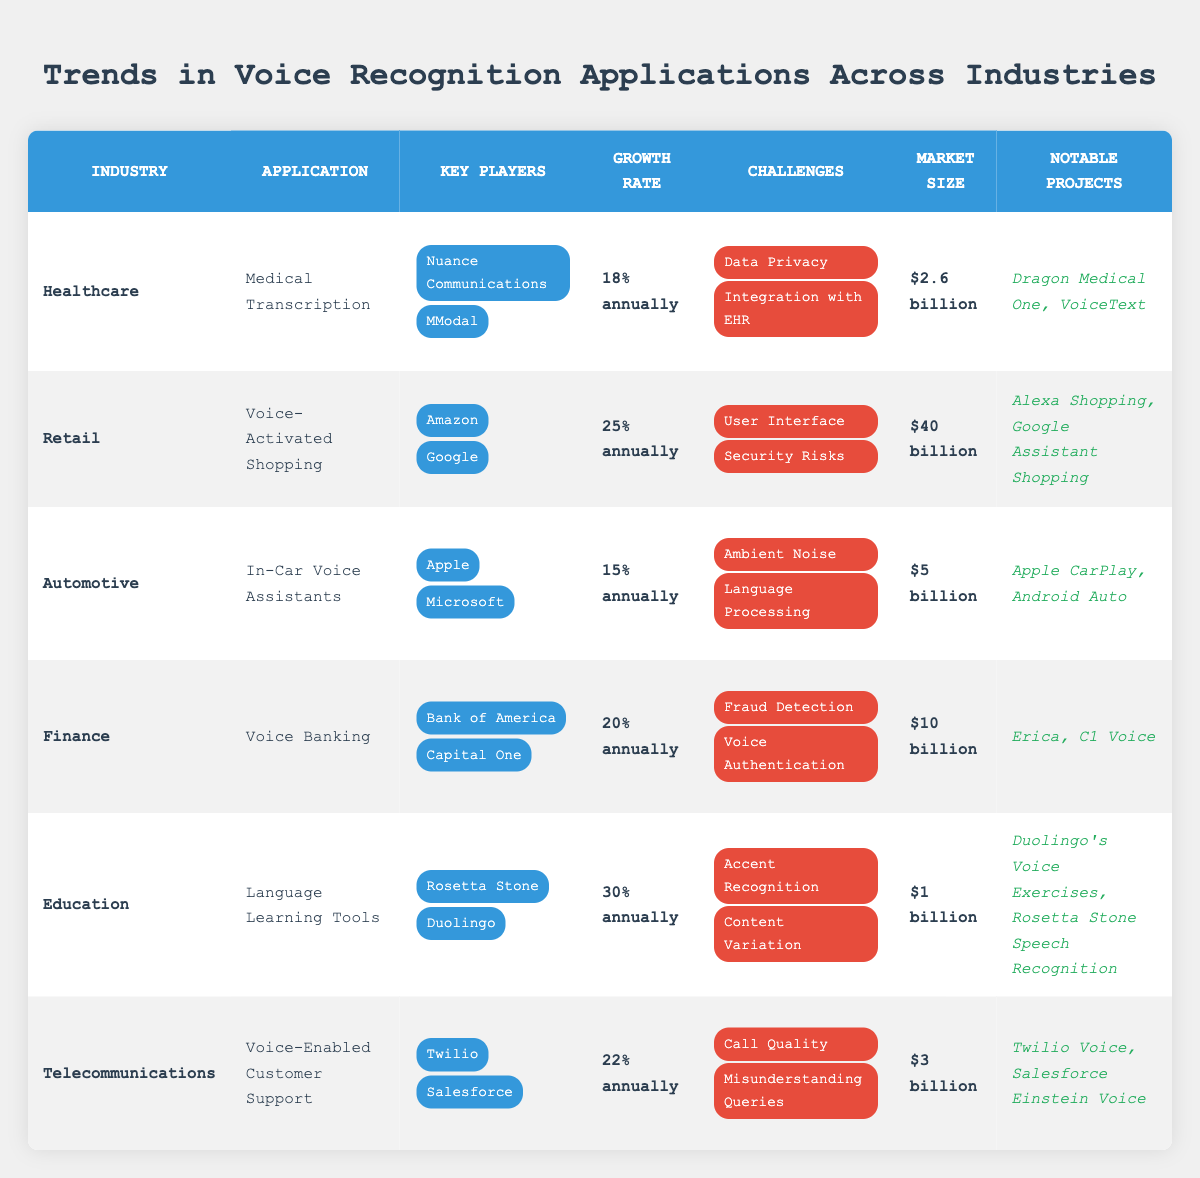What is the growth rate for Voice Banking in the Finance industry? The table indicates that the growth rate for Voice Banking is specified under the Finance industry, which is listed as "20% annually."
Answer: 20% annually Which industry has the highest market size according to the table? To find the industry with the highest market size, we compare the market size values: Healthcare ($2.6 billion), Retail ($40 billion), Automotive ($5 billion), Finance ($10 billion), Education ($1 billion), and Telecommunications ($3 billion). Retail has the highest value at $40 billion.
Answer: Retail What are the challenges faced by the Automotive industry in voice recognition applications? The challenges for the Automotive industry are listed under the corresponding row, which are "Ambient Noise" and "Language Processing."
Answer: Ambient Noise, Language Processing What is the average growth rate of voice recognition applications across the listed industries? To find the average growth rate, we convert each growth rate to a percentage: Healthcare (18%), Retail (25%), Automotive (15%), Finance (20%), Education (30%), and Telecommunications (22%). We sum these growth rates: 18 + 25 + 15 + 20 + 30 + 22 = 130. Then divide by the number of industries (6): 130/6 ≈ 21.67%.
Answer: 21.67% Is there a notable project listed under the Telecommunication industry? The table presents "Twilio Voice" and "Salesforce Einstein Voice" under the notable projects for Telecommunications, thus confirming that there are notable projects listed.
Answer: Yes Which industry has the lowest growth rate, and what is that rate? By examining the growth rates – Healthcare (18%), Retail (25%), Automotive (15%), Finance (20%), Education (30%), and Telecommunications (22%), Automotive has the lowest rate at 15%.
Answer: Automotive, 15% How many key players are listed for the Education industry? The Education industry lists two key players: "Rosetta Stone" and "Duolingo." Thus, there are two key players.
Answer: 2 What market size is associated with Language Learning Tools? The table states that the market size for Language Learning Tools, categorized under the Education industry, is "$1 billion."
Answer: $1 billion Which industry's voice recognition application grows the fastest and by what rate? Looking at the growth rates of all industries, the highest rate is found in the Education industry at "30% annually" for Language Learning Tools, indicating it has the fastest growth.
Answer: Education, 30% annually Is there any mention of fraud detection as a challenge for voice recognition? The Finance industry lists "Fraud Detection" as a challenge indicating that it is indeed mentioned.
Answer: Yes Which industry has the second-largest market size, and what is that size? The two largest market sizes in descending order are Retail ($40 billion) and Finance ($10 billion), making Finance the second-largest.
Answer: Finance, $10 billion 